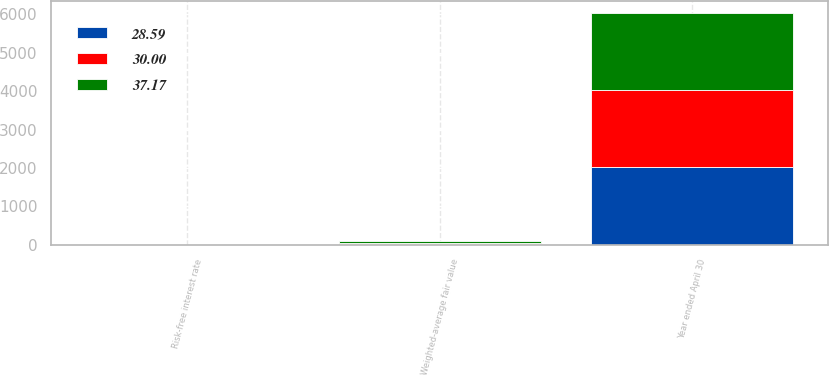Convert chart to OTSL. <chart><loc_0><loc_0><loc_500><loc_500><stacked_bar_chart><ecel><fcel>Year ended April 30<fcel>Risk-free interest rate<fcel>Weighted-average fair value<nl><fcel>30<fcel>2016<fcel>0.95<fcel>30<nl><fcel>37.17<fcel>2015<fcel>0.81<fcel>37.17<nl><fcel>28.59<fcel>2014<fcel>0.61<fcel>28.59<nl></chart> 